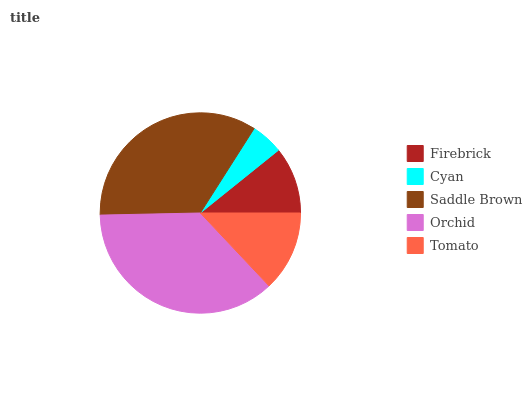Is Cyan the minimum?
Answer yes or no. Yes. Is Orchid the maximum?
Answer yes or no. Yes. Is Saddle Brown the minimum?
Answer yes or no. No. Is Saddle Brown the maximum?
Answer yes or no. No. Is Saddle Brown greater than Cyan?
Answer yes or no. Yes. Is Cyan less than Saddle Brown?
Answer yes or no. Yes. Is Cyan greater than Saddle Brown?
Answer yes or no. No. Is Saddle Brown less than Cyan?
Answer yes or no. No. Is Tomato the high median?
Answer yes or no. Yes. Is Tomato the low median?
Answer yes or no. Yes. Is Saddle Brown the high median?
Answer yes or no. No. Is Orchid the low median?
Answer yes or no. No. 